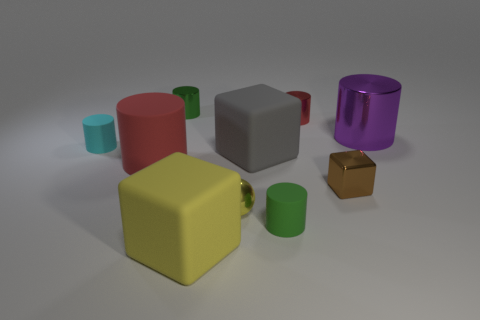There is a tiny rubber object that is behind the big gray cube; does it have the same color as the large metallic cylinder?
Your response must be concise. No. The cyan rubber cylinder is what size?
Your answer should be compact. Small. There is another cube that is the same size as the yellow rubber cube; what material is it?
Your response must be concise. Rubber. The large block that is behind the red rubber cylinder is what color?
Keep it short and to the point. Gray. What number of brown objects are there?
Offer a very short reply. 1. There is a red cylinder that is on the left side of the small thing that is in front of the yellow metal ball; are there any small brown things left of it?
Your answer should be very brief. No. The green shiny thing that is the same size as the shiny cube is what shape?
Your answer should be very brief. Cylinder. What number of other objects are the same color as the large metal cylinder?
Your answer should be compact. 0. What is the tiny ball made of?
Provide a short and direct response. Metal. What number of other things are there of the same material as the tiny brown block
Offer a terse response. 4. 